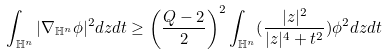<formula> <loc_0><loc_0><loc_500><loc_500>\int _ { \mathbb { H } ^ { n } } | \nabla _ { \mathbb { H } ^ { n } } \phi | ^ { 2 } d z d t \geq \left ( \frac { Q - 2 } { 2 } \right ) ^ { 2 } \int _ { \mathbb { H } ^ { n } } ( \frac { | z | ^ { 2 } } { | z | ^ { 4 } + t ^ { 2 } } ) \phi ^ { 2 } d z d t</formula> 